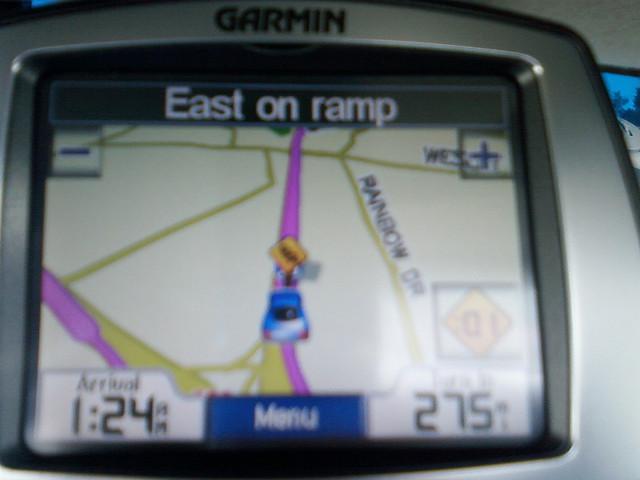Is this a computer screen?
Keep it brief. No. What is the arrival time?
Keep it brief. 1:24. What direction are they traveling?
Answer briefly. East. 